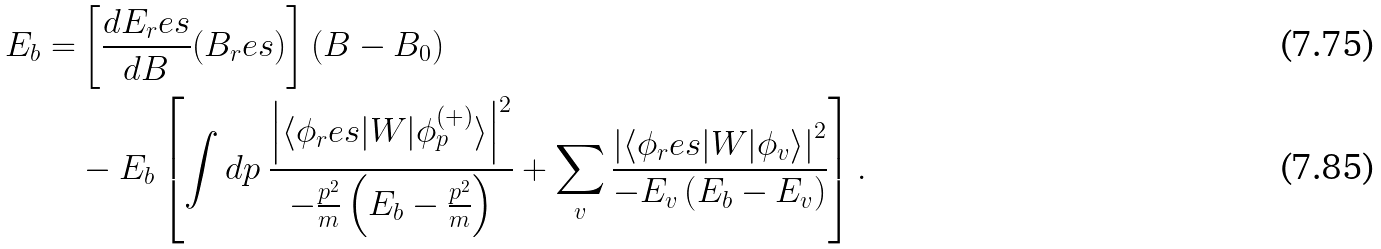<formula> <loc_0><loc_0><loc_500><loc_500>E _ { b } = & \left [ \frac { d E _ { r } e s } { d B } ( B _ { r } e s ) \right ] ( B - B _ { 0 } ) \\ & - E _ { b } \left [ \int d p \ \frac { \left | \langle \phi _ { r } e s | W | \phi _ { p } ^ { ( + ) } \rangle \right | ^ { 2 } } { - \frac { p ^ { 2 } } { m } \left ( E _ { b } - \frac { p ^ { 2 } } { m } \right ) } + \sum _ { v } \frac { \left | \langle \phi _ { r } e s | W | \phi _ { v } \rangle \right | ^ { 2 } } { - E _ { v } \left ( E _ { b } - E _ { v } \right ) } \right ] .</formula> 